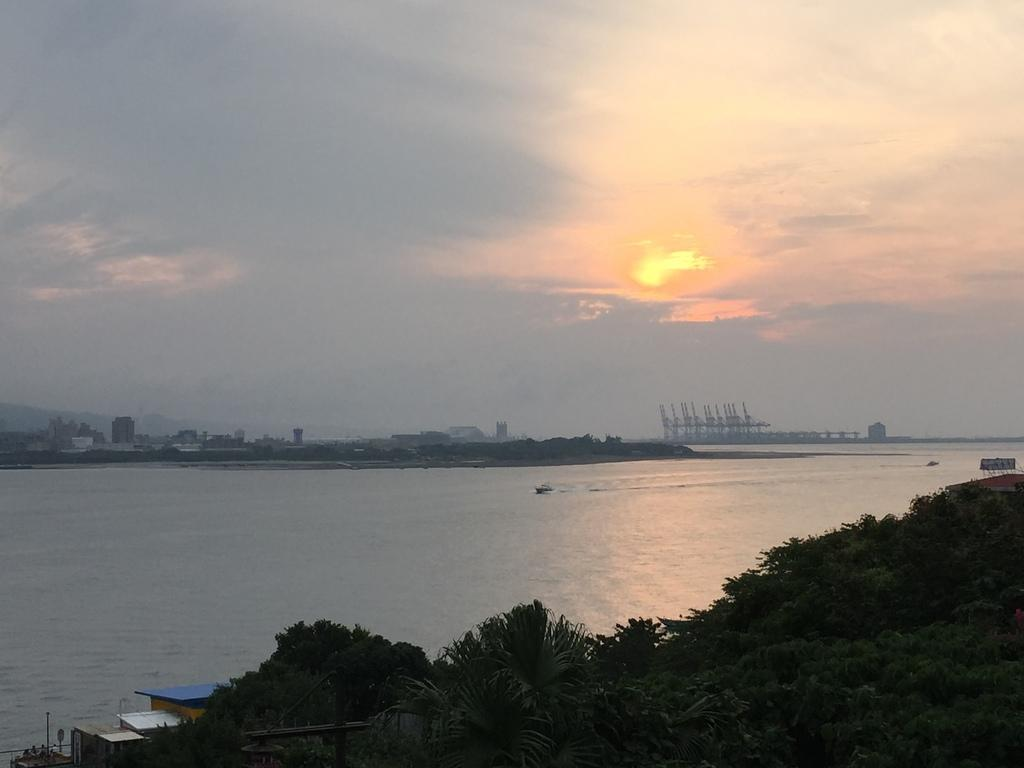What type of natural elements can be seen in the image? There are trees in the image. What type of man-made structures are present in the image? There are buildings in the image. What body of water is visible in the image? There is water visible in the image. What type of vehicles can be seen in the background of the image? There are boats in the background of the image. What part of the natural environment is visible in the background of the image? The sky is visible in the background of the image. Where is the bear located in the image? There is no bear present in the image. What type of vase is placed on the water in the image? There is no vase present in the image. 